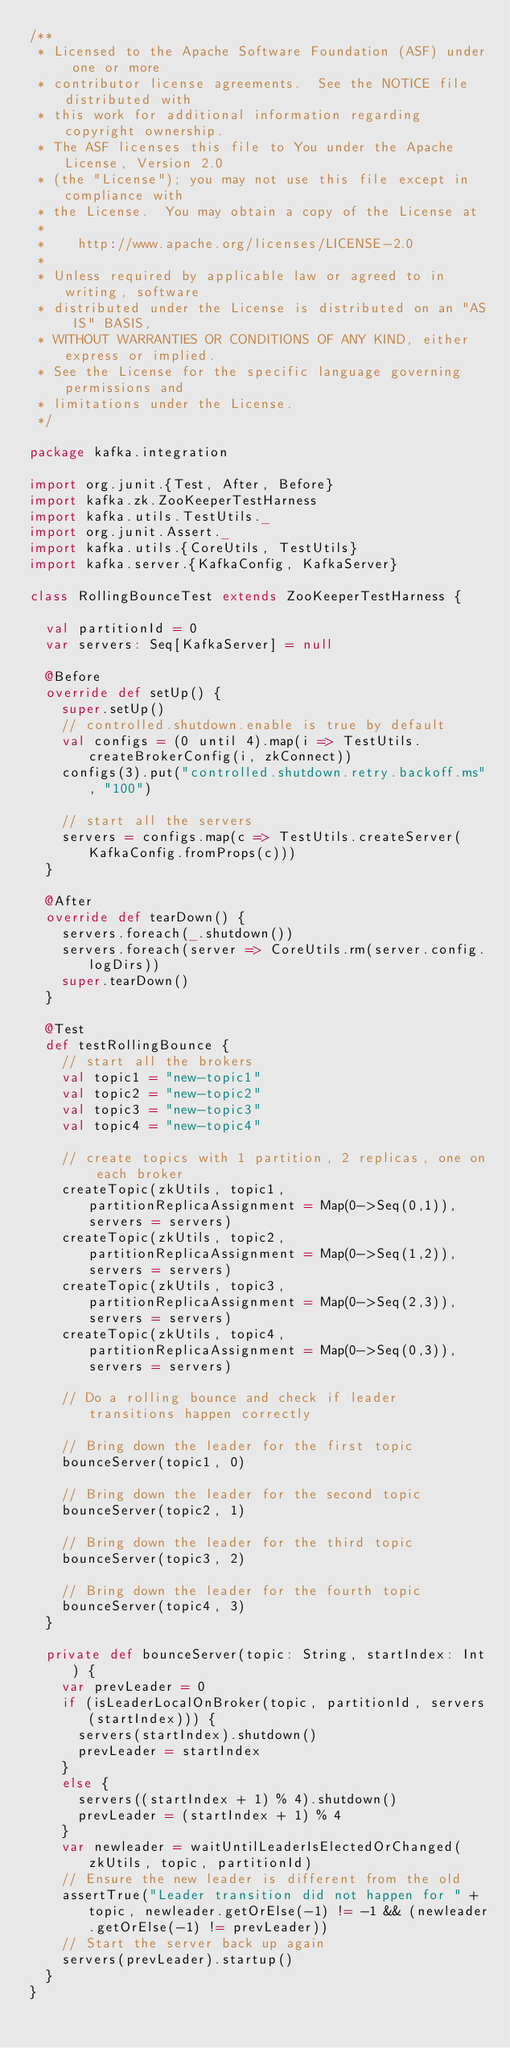Convert code to text. <code><loc_0><loc_0><loc_500><loc_500><_Scala_>/**
 * Licensed to the Apache Software Foundation (ASF) under one or more
 * contributor license agreements.  See the NOTICE file distributed with
 * this work for additional information regarding copyright ownership.
 * The ASF licenses this file to You under the Apache License, Version 2.0
 * (the "License"); you may not use this file except in compliance with
 * the License.  You may obtain a copy of the License at
 *
 *    http://www.apache.org/licenses/LICENSE-2.0
 *
 * Unless required by applicable law or agreed to in writing, software
 * distributed under the License is distributed on an "AS IS" BASIS,
 * WITHOUT WARRANTIES OR CONDITIONS OF ANY KIND, either express or implied.
 * See the License for the specific language governing permissions and
 * limitations under the License.
 */

package kafka.integration

import org.junit.{Test, After, Before}
import kafka.zk.ZooKeeperTestHarness
import kafka.utils.TestUtils._
import org.junit.Assert._
import kafka.utils.{CoreUtils, TestUtils}
import kafka.server.{KafkaConfig, KafkaServer}

class RollingBounceTest extends ZooKeeperTestHarness {

  val partitionId = 0
  var servers: Seq[KafkaServer] = null

  @Before
  override def setUp() {
    super.setUp()
    // controlled.shutdown.enable is true by default
    val configs = (0 until 4).map(i => TestUtils.createBrokerConfig(i, zkConnect))
    configs(3).put("controlled.shutdown.retry.backoff.ms", "100")
 
    // start all the servers
    servers = configs.map(c => TestUtils.createServer(KafkaConfig.fromProps(c)))
  }

  @After
  override def tearDown() {
    servers.foreach(_.shutdown())
    servers.foreach(server => CoreUtils.rm(server.config.logDirs))
    super.tearDown()
  }

  @Test
  def testRollingBounce {
    // start all the brokers
    val topic1 = "new-topic1"
    val topic2 = "new-topic2"
    val topic3 = "new-topic3"
    val topic4 = "new-topic4"

    // create topics with 1 partition, 2 replicas, one on each broker
    createTopic(zkUtils, topic1, partitionReplicaAssignment = Map(0->Seq(0,1)), servers = servers)
    createTopic(zkUtils, topic2, partitionReplicaAssignment = Map(0->Seq(1,2)), servers = servers)
    createTopic(zkUtils, topic3, partitionReplicaAssignment = Map(0->Seq(2,3)), servers = servers)
    createTopic(zkUtils, topic4, partitionReplicaAssignment = Map(0->Seq(0,3)), servers = servers)

    // Do a rolling bounce and check if leader transitions happen correctly

    // Bring down the leader for the first topic
    bounceServer(topic1, 0)

    // Bring down the leader for the second topic
    bounceServer(topic2, 1)

    // Bring down the leader for the third topic
    bounceServer(topic3, 2)

    // Bring down the leader for the fourth topic
    bounceServer(topic4, 3)
  }

  private def bounceServer(topic: String, startIndex: Int) {
    var prevLeader = 0
    if (isLeaderLocalOnBroker(topic, partitionId, servers(startIndex))) {
      servers(startIndex).shutdown()
      prevLeader = startIndex
    }
    else {
      servers((startIndex + 1) % 4).shutdown()
      prevLeader = (startIndex + 1) % 4
    }
    var newleader = waitUntilLeaderIsElectedOrChanged(zkUtils, topic, partitionId)
    // Ensure the new leader is different from the old
    assertTrue("Leader transition did not happen for " + topic, newleader.getOrElse(-1) != -1 && (newleader.getOrElse(-1) != prevLeader))
    // Start the server back up again
    servers(prevLeader).startup()
  }
}
</code> 